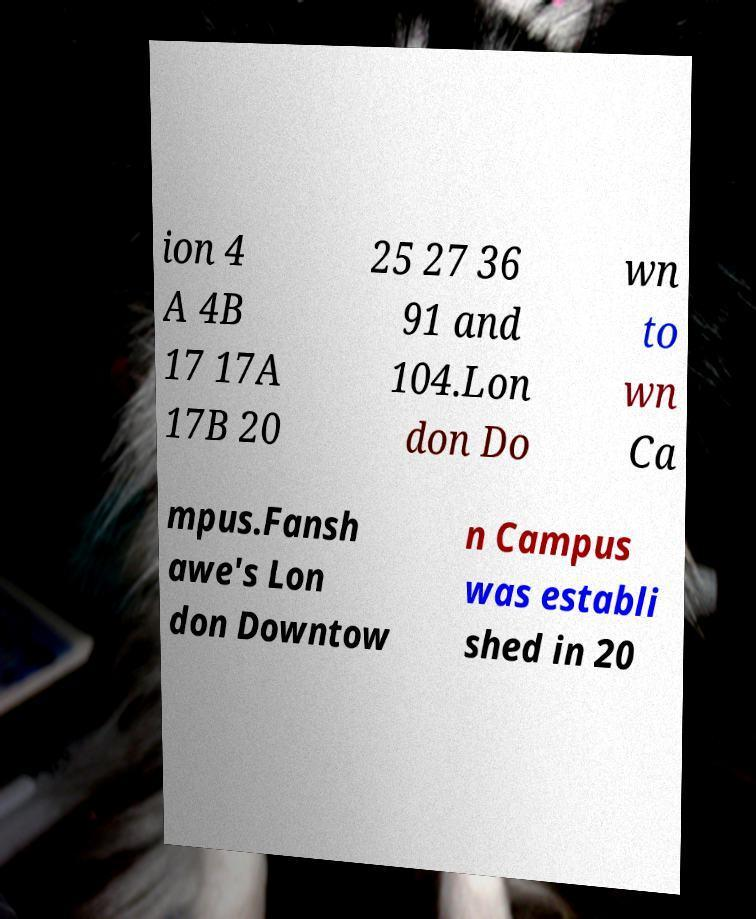For documentation purposes, I need the text within this image transcribed. Could you provide that? ion 4 A 4B 17 17A 17B 20 25 27 36 91 and 104.Lon don Do wn to wn Ca mpus.Fansh awe's Lon don Downtow n Campus was establi shed in 20 